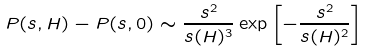Convert formula to latex. <formula><loc_0><loc_0><loc_500><loc_500>P ( s , H ) - P ( s , 0 ) \sim \frac { s ^ { 2 } } { s ( H ) ^ { 3 } } \exp \left [ - \frac { s ^ { 2 } } { s ( H ) ^ { 2 } } \right ]</formula> 